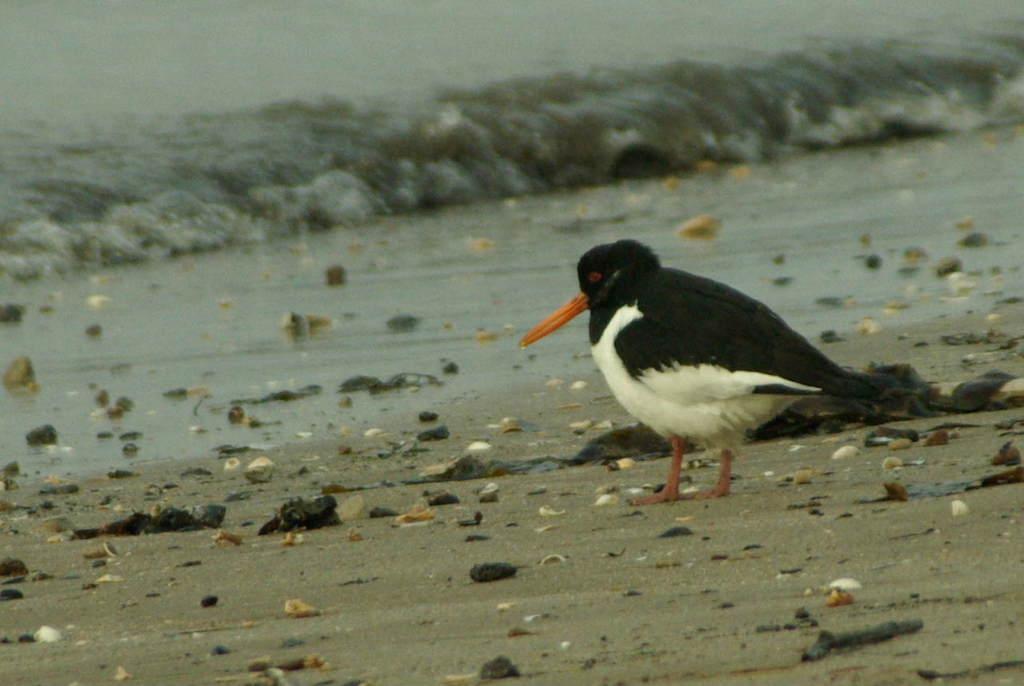Describe this image in one or two sentences. This picture is clicked outside the city. On the right there is a black and white color bird with a long beak, standing on the ground and there are some objects lying on the ground. In the background we can see a water body and the ripples in the water body. 